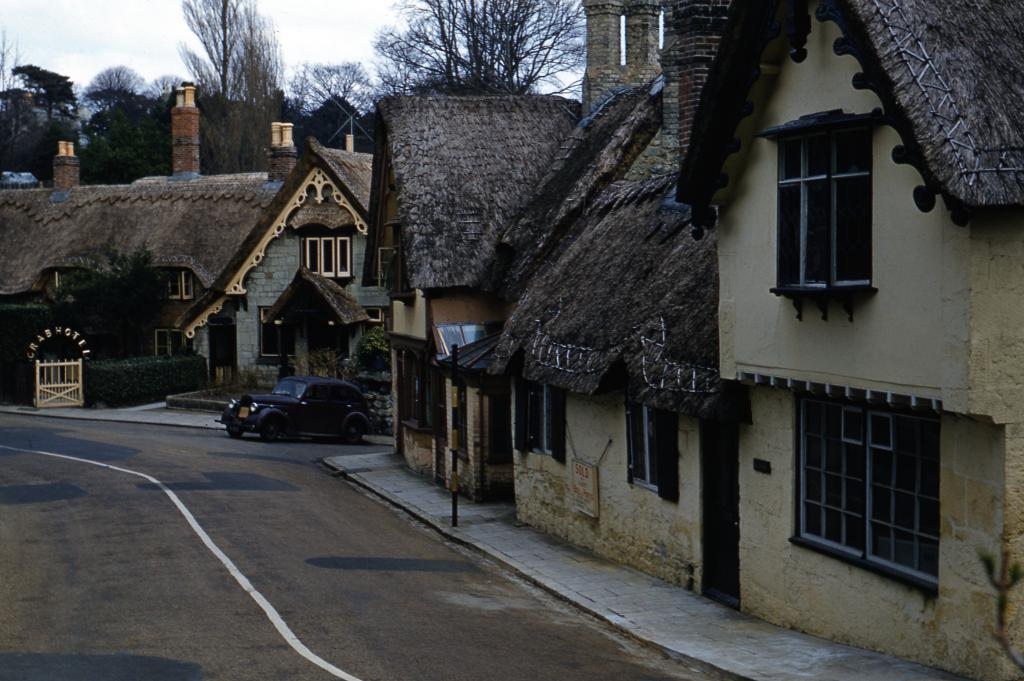What can be seen on the left side of the image? There is a road on the left side of the image. What is located on the right side of the image? There are homes on the right side of the image. Can you describe what is in the middle of the homes? There is a car in the middle of the homes. What type of vegetation is visible behind the homes? Trees are visible behind the homes. What is visible above the scene? The sky is visible above the scene. What rule is being enforced by the car in the image? There is no indication in the image that the car is enforcing any rules. What event led to the death of the person in the image? There is no person or death present in the image. What type of voyage is the car embarking on in the image? The car is not embarking on any voyage in the image; it is parked between the homes. 